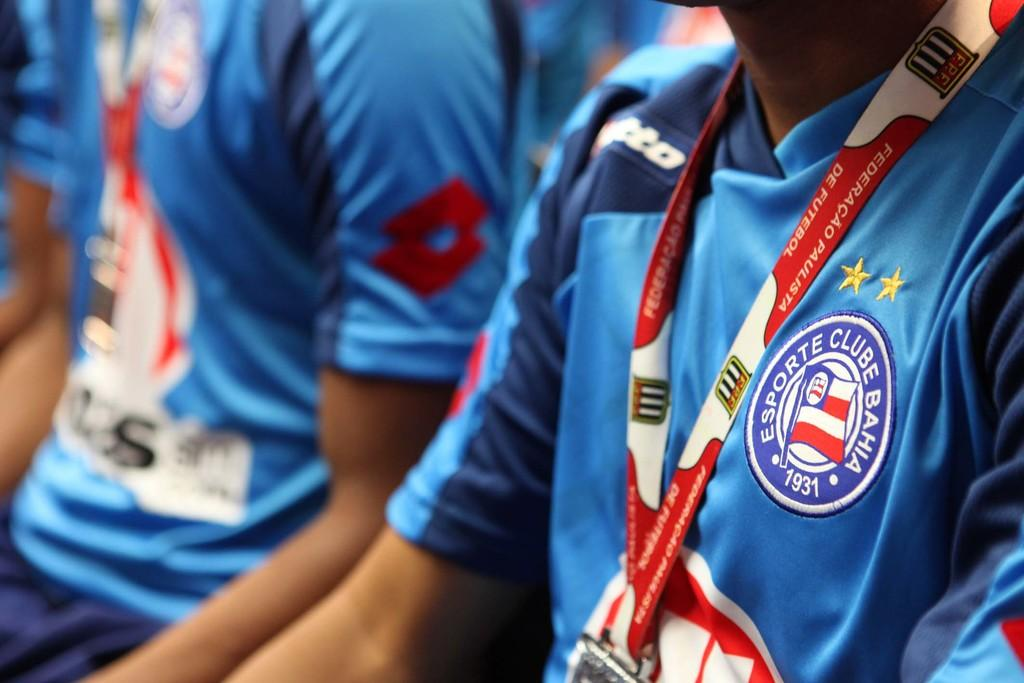<image>
Describe the image concisely. the word esporte that is on a jersey 